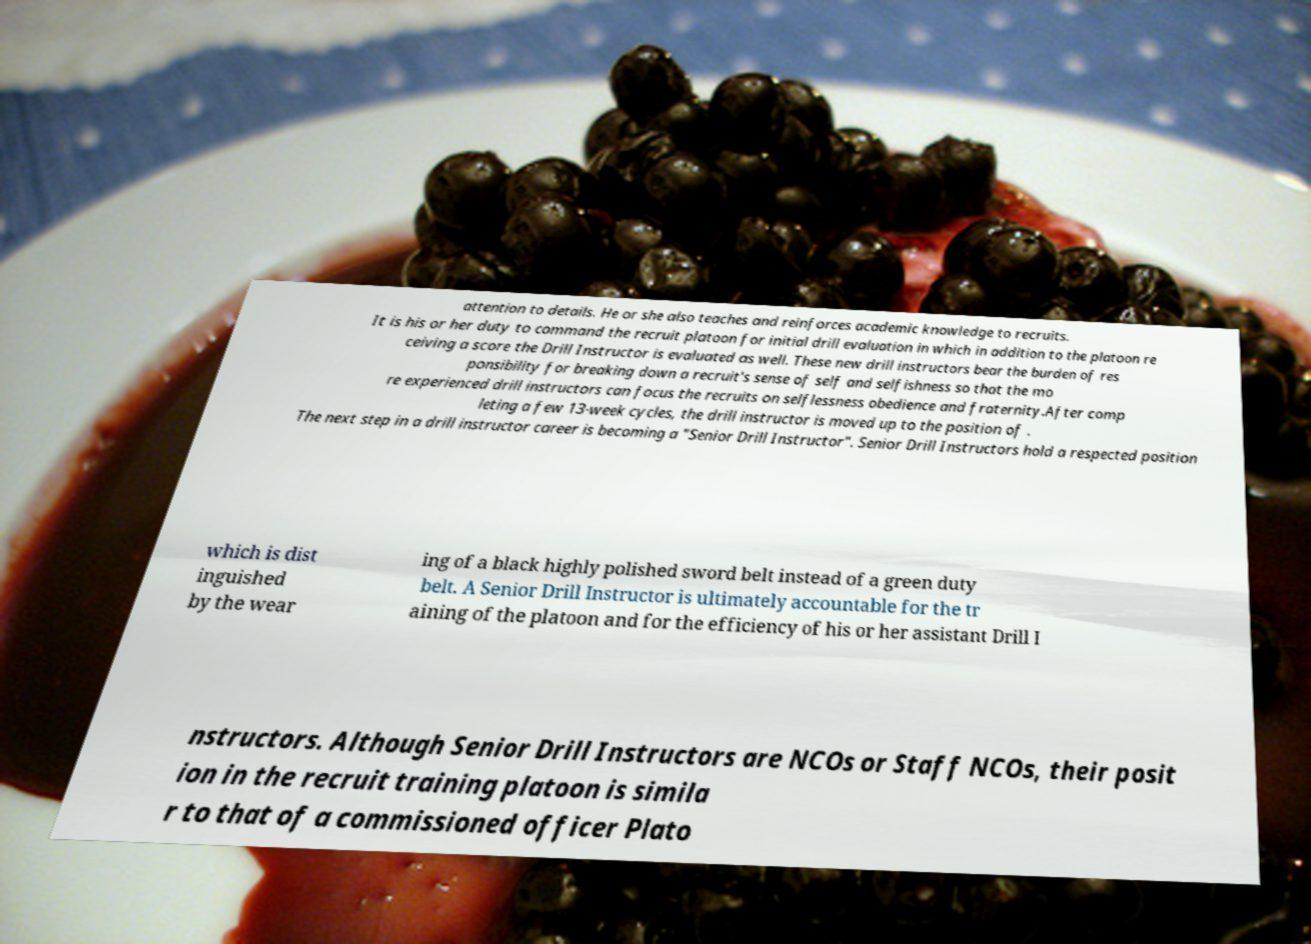Can you read and provide the text displayed in the image?This photo seems to have some interesting text. Can you extract and type it out for me? attention to details. He or she also teaches and reinforces academic knowledge to recruits. It is his or her duty to command the recruit platoon for initial drill evaluation in which in addition to the platoon re ceiving a score the Drill Instructor is evaluated as well. These new drill instructors bear the burden of res ponsibility for breaking down a recruit's sense of self and selfishness so that the mo re experienced drill instructors can focus the recruits on selflessness obedience and fraternity.After comp leting a few 13-week cycles, the drill instructor is moved up to the position of . The next step in a drill instructor career is becoming a "Senior Drill Instructor". Senior Drill Instructors hold a respected position which is dist inguished by the wear ing of a black highly polished sword belt instead of a green duty belt. A Senior Drill Instructor is ultimately accountable for the tr aining of the platoon and for the efficiency of his or her assistant Drill I nstructors. Although Senior Drill Instructors are NCOs or Staff NCOs, their posit ion in the recruit training platoon is simila r to that of a commissioned officer Plato 